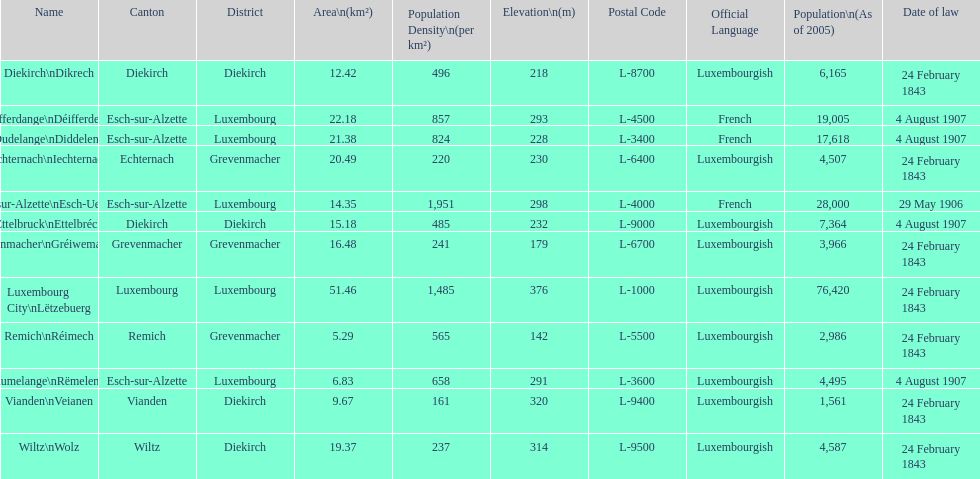Could you parse the entire table? {'header': ['Name', 'Canton', 'District', 'Area\\n(km²)', 'Population Density\\n(per km²)', 'Elevation\\n(m)', 'Postal Code', 'Official Language', 'Population\\n(As of 2005)', 'Date of law'], 'rows': [['Diekirch\\nDikrech', 'Diekirch', 'Diekirch', '12.42', '496', '218', 'L-8700', 'Luxembourgish', '6,165', '24 February 1843'], ['Differdange\\nDéifferdeng', 'Esch-sur-Alzette', 'Luxembourg', '22.18', '857', '293', 'L-4500', 'French', '19,005', '4 August 1907'], ['Dudelange\\nDiddeleng', 'Esch-sur-Alzette', 'Luxembourg', '21.38', '824', '228', 'L-3400', 'French', '17,618', '4 August 1907'], ['Echternach\\nIechternach', 'Echternach', 'Grevenmacher', '20.49', '220', '230', 'L-6400', 'Luxembourgish', '4,507', '24 February 1843'], ['Esch-sur-Alzette\\nEsch-Uelzecht', 'Esch-sur-Alzette', 'Luxembourg', '14.35', '1,951', '298', 'L-4000', 'French', '28,000', '29 May 1906'], ['Ettelbruck\\nEttelbréck', 'Diekirch', 'Diekirch', '15.18', '485', '232', 'L-9000', 'Luxembourgish', '7,364', '4 August 1907'], ['Grevenmacher\\nGréiwemaacher', 'Grevenmacher', 'Grevenmacher', '16.48', '241', '179', 'L-6700', 'Luxembourgish', '3,966', '24 February 1843'], ['Luxembourg City\\nLëtzebuerg', 'Luxembourg', 'Luxembourg', '51.46', '1,485', '376', 'L-1000', 'Luxembourgish', '76,420', '24 February 1843'], ['Remich\\nRéimech', 'Remich', 'Grevenmacher', '5.29', '565', '142', 'L-5500', 'Luxembourgish', '2,986', '24 February 1843'], ['Rumelange\\nRëmeleng', 'Esch-sur-Alzette', 'Luxembourg', '6.83', '658', '291', 'L-3600', 'Luxembourgish', '4,495', '4 August 1907'], ['Vianden\\nVeianen', 'Vianden', 'Diekirch', '9.67', '161', '320', 'L-9400', 'Luxembourgish', '1,561', '24 February 1843'], ['Wiltz\\nWolz', 'Wiltz', 'Diekirch', '19.37', '237', '314', 'L-9500', 'Luxembourgish', '4,587', '24 February 1843']]} What canton is the most populated? Luxembourg. 